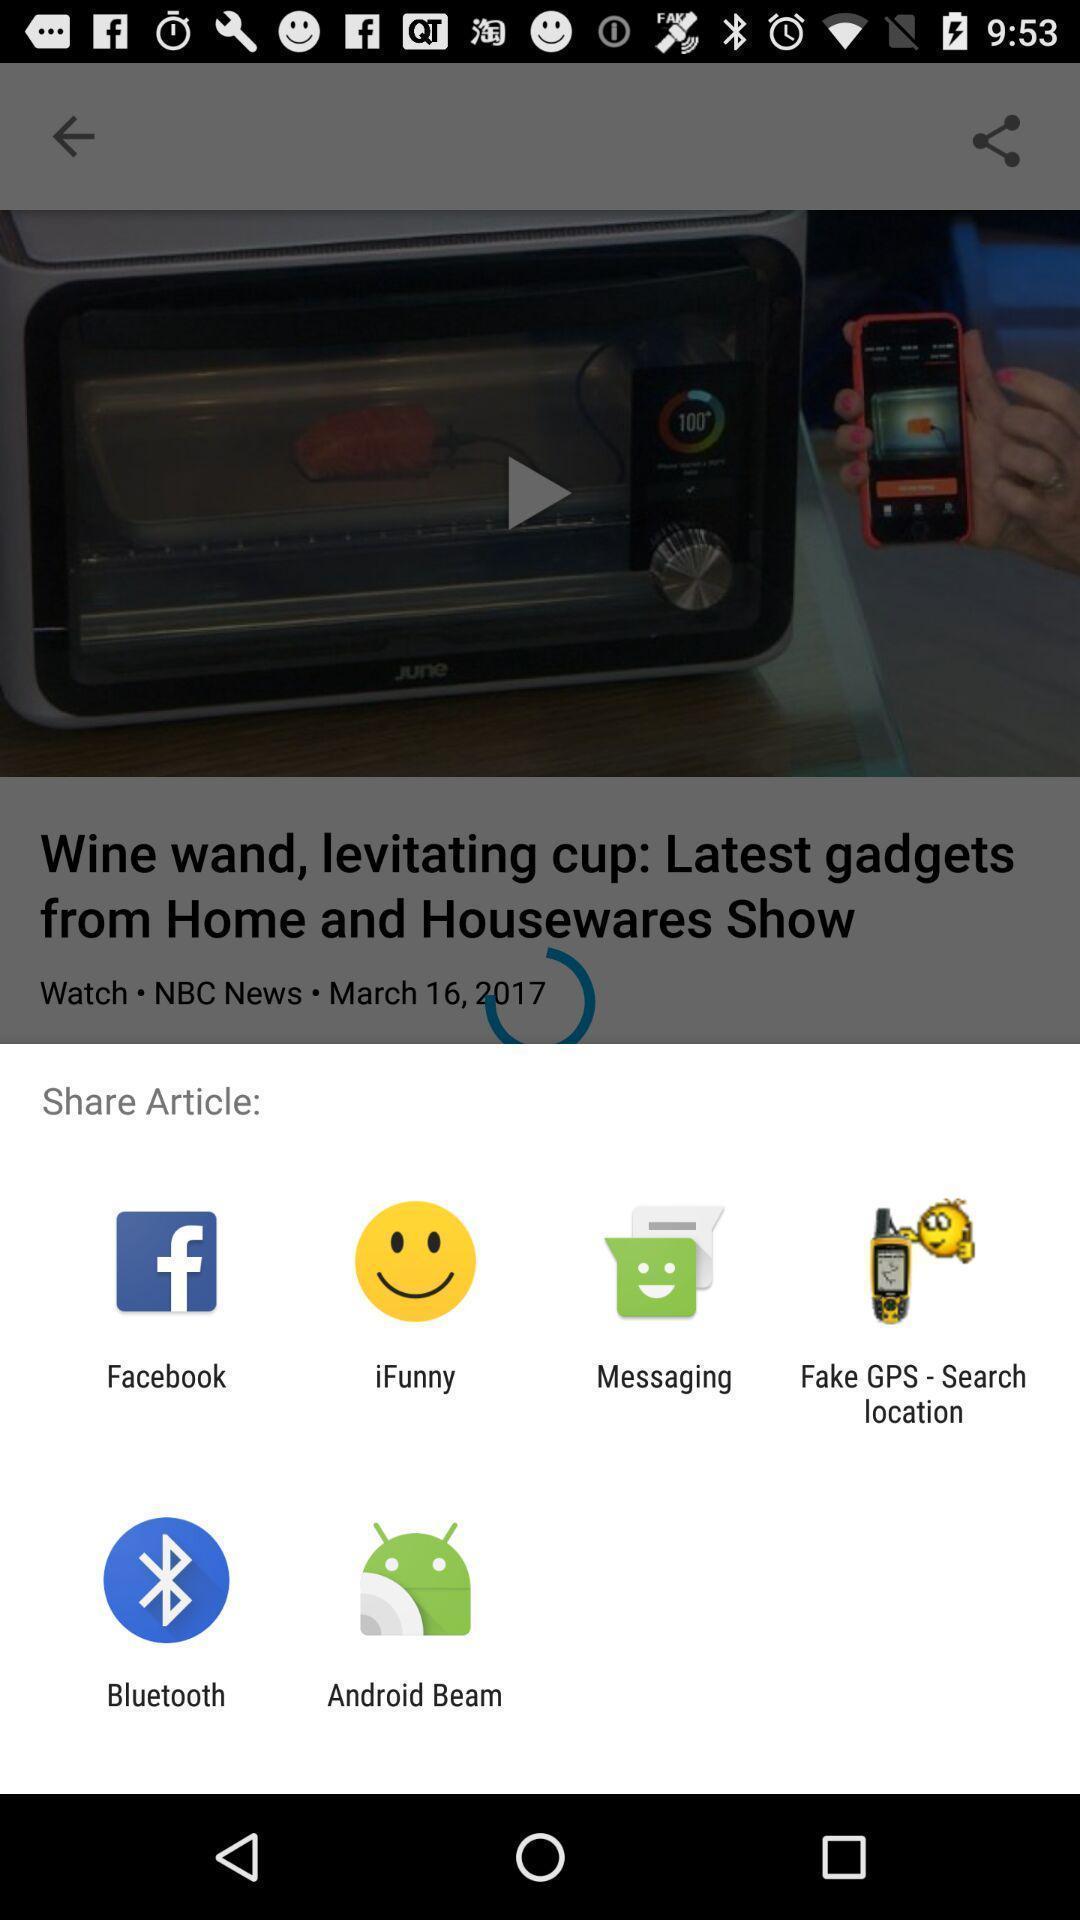Tell me about the visual elements in this screen capture. Pop-up widget displaying multiple sharing apps. 